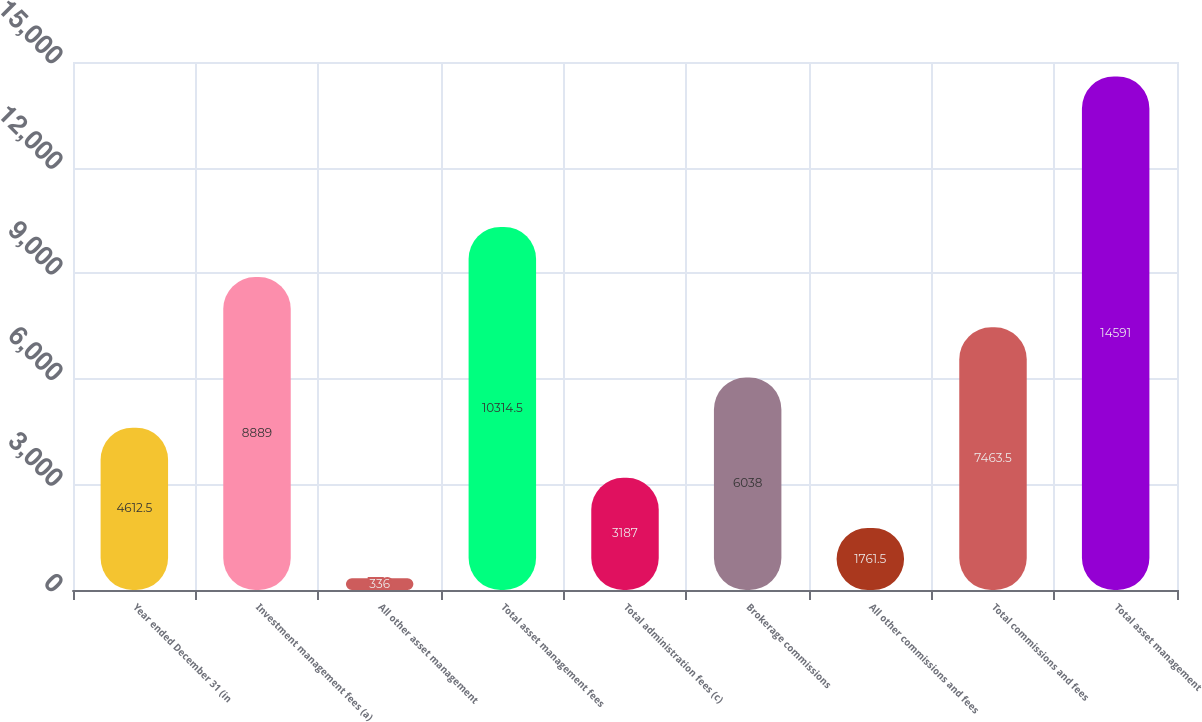Convert chart. <chart><loc_0><loc_0><loc_500><loc_500><bar_chart><fcel>Year ended December 31 (in<fcel>Investment management fees (a)<fcel>All other asset management<fcel>Total asset management fees<fcel>Total administration fees (c)<fcel>Brokerage commissions<fcel>All other commissions and fees<fcel>Total commissions and fees<fcel>Total asset management<nl><fcel>4612.5<fcel>8889<fcel>336<fcel>10314.5<fcel>3187<fcel>6038<fcel>1761.5<fcel>7463.5<fcel>14591<nl></chart> 